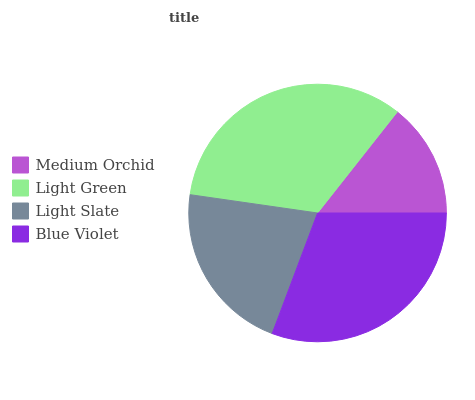Is Medium Orchid the minimum?
Answer yes or no. Yes. Is Light Green the maximum?
Answer yes or no. Yes. Is Light Slate the minimum?
Answer yes or no. No. Is Light Slate the maximum?
Answer yes or no. No. Is Light Green greater than Light Slate?
Answer yes or no. Yes. Is Light Slate less than Light Green?
Answer yes or no. Yes. Is Light Slate greater than Light Green?
Answer yes or no. No. Is Light Green less than Light Slate?
Answer yes or no. No. Is Blue Violet the high median?
Answer yes or no. Yes. Is Light Slate the low median?
Answer yes or no. Yes. Is Medium Orchid the high median?
Answer yes or no. No. Is Blue Violet the low median?
Answer yes or no. No. 